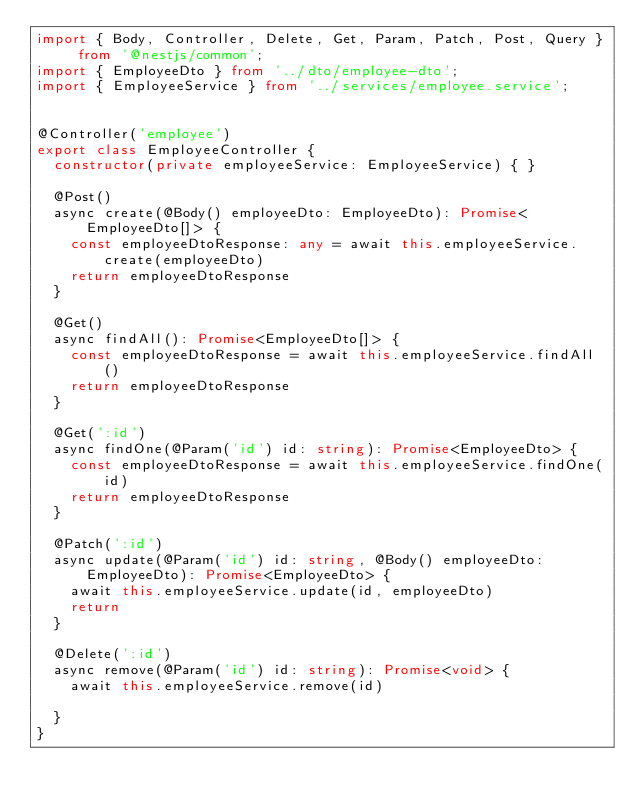Convert code to text. <code><loc_0><loc_0><loc_500><loc_500><_TypeScript_>import { Body, Controller, Delete, Get, Param, Patch, Post, Query } from '@nestjs/common';
import { EmployeeDto } from '../dto/employee-dto';
import { EmployeeService } from '../services/employee.service';


@Controller('employee')
export class EmployeeController {
  constructor(private employeeService: EmployeeService) { }

  @Post()
  async create(@Body() employeeDto: EmployeeDto): Promise<EmployeeDto[]> {
    const employeeDtoResponse: any = await this.employeeService.create(employeeDto)
    return employeeDtoResponse
  }

  @Get()
  async findAll(): Promise<EmployeeDto[]> {
    const employeeDtoResponse = await this.employeeService.findAll()
    return employeeDtoResponse
  }

  @Get(':id')
  async findOne(@Param('id') id: string): Promise<EmployeeDto> {
    const employeeDtoResponse = await this.employeeService.findOne(id)
    return employeeDtoResponse
  }

  @Patch(':id')
  async update(@Param('id') id: string, @Body() employeeDto: EmployeeDto): Promise<EmployeeDto> {
    await this.employeeService.update(id, employeeDto)
    return
  }

  @Delete(':id')
  async remove(@Param('id') id: string): Promise<void> {
    await this.employeeService.remove(id)

  }
}


</code> 